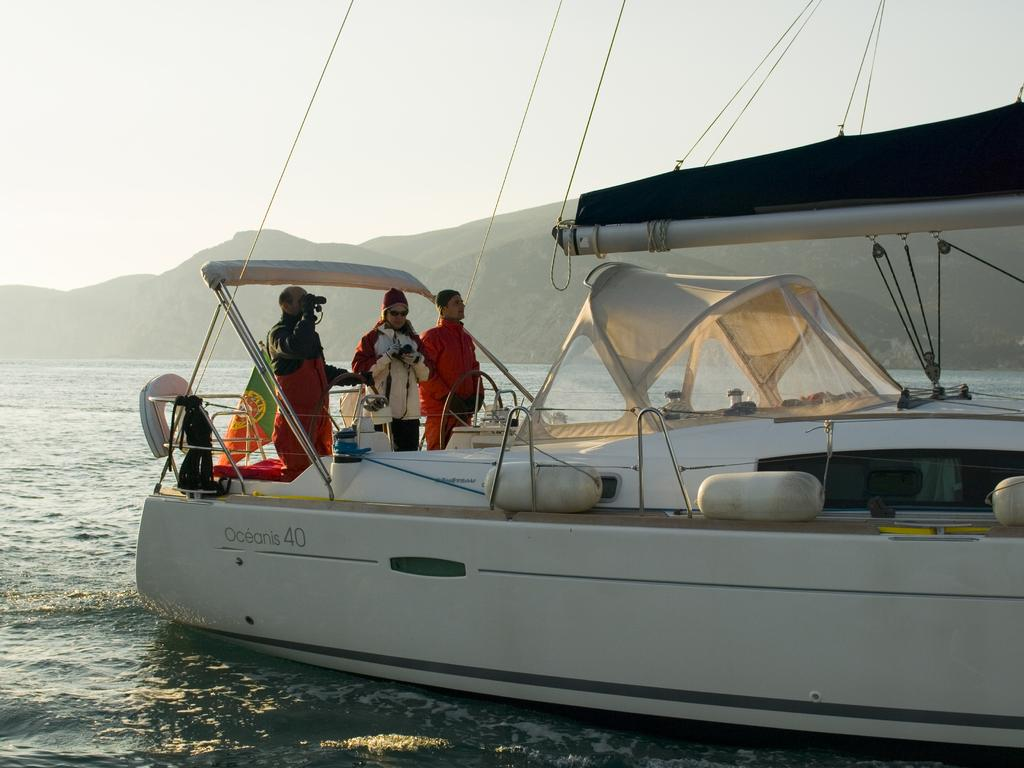What are the people in the image doing? The people in the image are in a boat. Where is the boat located? The boat is on a river. What is one person holding in the image? One person is holding a binocular. What can be seen in the background of the image? There are mountains and the sky visible in the background. How many basketballs can be seen in the image? There are no basketballs present in the image. What type of grip does the force of the river have on the boat? The image does not provide information about the force of the river or the grip of the boat, so it cannot be determined from the image. 